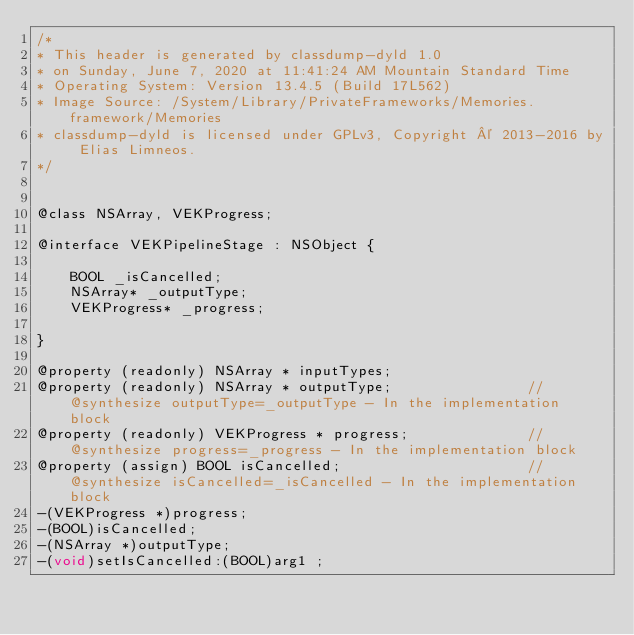Convert code to text. <code><loc_0><loc_0><loc_500><loc_500><_C_>/*
* This header is generated by classdump-dyld 1.0
* on Sunday, June 7, 2020 at 11:41:24 AM Mountain Standard Time
* Operating System: Version 13.4.5 (Build 17L562)
* Image Source: /System/Library/PrivateFrameworks/Memories.framework/Memories
* classdump-dyld is licensed under GPLv3, Copyright © 2013-2016 by Elias Limneos.
*/


@class NSArray, VEKProgress;

@interface VEKPipelineStage : NSObject {

	BOOL _isCancelled;
	NSArray* _outputType;
	VEKProgress* _progress;

}

@property (readonly) NSArray * inputTypes; 
@property (readonly) NSArray * outputType;                //@synthesize outputType=_outputType - In the implementation block
@property (readonly) VEKProgress * progress;              //@synthesize progress=_progress - In the implementation block
@property (assign) BOOL isCancelled;                      //@synthesize isCancelled=_isCancelled - In the implementation block
-(VEKProgress *)progress;
-(BOOL)isCancelled;
-(NSArray *)outputType;
-(void)setIsCancelled:(BOOL)arg1 ;</code> 